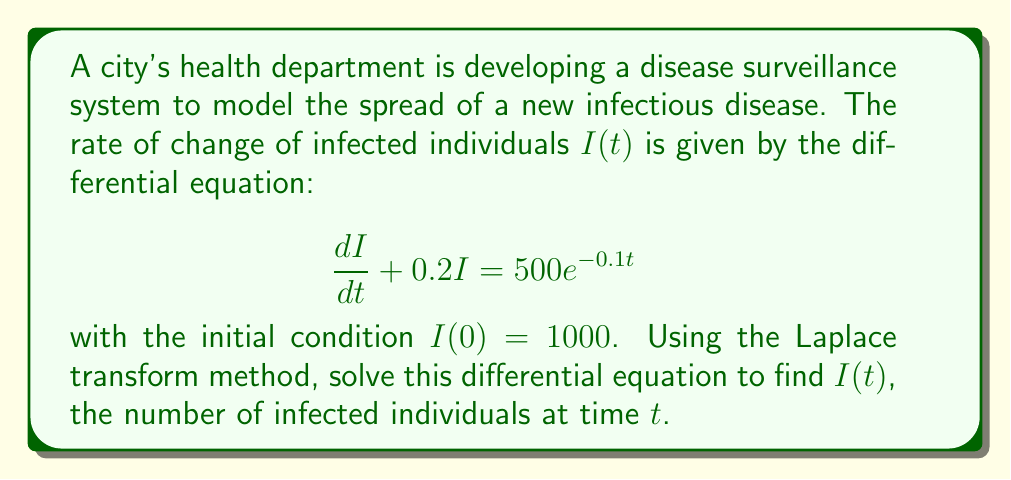Could you help me with this problem? Let's solve this step-by-step using the Laplace transform method:

1) First, take the Laplace transform of both sides of the equation:

   $\mathcal{L}\left\{\frac{dI}{dt} + 0.2I\right\} = \mathcal{L}\{500e^{-0.1t}\}$

2) Using the linearity property and the Laplace transform of the derivative:

   $s\mathcal{L}\{I\} - I(0) + 0.2\mathcal{L}\{I\} = \frac{500}{s+0.1}$

3) Let $\mathcal{L}\{I\} = F(s)$. Substituting the initial condition $I(0) = 1000$:

   $sF(s) - 1000 + 0.2F(s) = \frac{500}{s+0.1}$

4) Collecting terms with $F(s)$:

   $(s + 0.2)F(s) = 1000 + \frac{500}{s+0.1}$

5) Solving for $F(s)$:

   $F(s) = \frac{1000}{s + 0.2} + \frac{500}{(s + 0.2)(s + 0.1)}$

6) Decompose the second term using partial fractions:

   $F(s) = \frac{1000}{s + 0.2} + \frac{A}{s + 0.2} + \frac{B}{s + 0.1}$

   where $A$ and $B$ are constants to be determined.

7) Finding $A$ and $B$:

   $500 = A(s + 0.1) + B(s + 0.2)$
   
   When $s = -0.2$: $500 = A(-0.1) \Rightarrow A = -5000$
   When $s = -0.1$: $500 = B(0.1) \Rightarrow B = 5000$

8) Therefore:

   $F(s) = \frac{1000}{s + 0.2} - \frac{5000}{s + 0.2} + \frac{5000}{s + 0.1}$

9) Taking the inverse Laplace transform:

   $I(t) = 1000e^{-0.2t} - 5000e^{-0.2t} + 5000e^{-0.1t}$

10) Simplifying:

    $I(t) = 5000e^{-0.1t} - 4000e^{-0.2t}$

This is the solution for $I(t)$, representing the number of infected individuals at time $t$.
Answer: $I(t) = 5000e^{-0.1t} - 4000e^{-0.2t}$ 